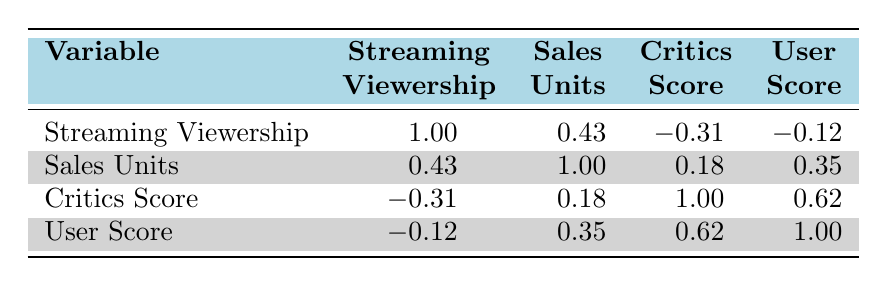What is the correlation coefficient between streaming viewership hours and game sales units? The correlation table indicates that the value for the correlation between streaming viewership and sales units is 0.43.
Answer: 0.43 Is there a positive correlation between user score and game sales units? Yes, the correlation value between user score and sales units is 0.35, which indicates a positive relationship.
Answer: Yes What is the overall correlation coefficient for critics score with streaming viewership? The table shows a correlation coefficient of -0.31 between critics score and streaming viewership, indicating a negative correlation.
Answer: -0.31 What is the average correlation coefficient between the user score and the critics score? The average correlation value is calculated by adding the correlation coefficients for user score (0.62) and user score (0.62) and dividing by the number of scores (1): (0.62)/1 = 0.62.
Answer: 0.62 Are the streaming viewership and user score negatively correlated? No, the table shows a correlation value of -0.12 between streaming viewership and user score, which indicates a weak negative correlation.
Answer: No What is the maximum correlation value found in the table? The maximum correlation value is 1.00, which is the correlation of each variable with itself (streaming viewership with itself).
Answer: 1.00 How would you interpret the correlation coefficient of 0.43 between streaming viewership and sales units? A correlation coefficient of 0.43 suggests a moderate positive relationship, meaning as streaming viewership increases, game sales units tend to also increase, but not perfectly.
Answer: Moderate positive relationship Is the critics score correlated with streaming viewership hours at a significant level? Yes, with -0.31 indicating a moderate negative correlation, reflects that as viewership hours increase, critics scores tend to decrease.
Answer: Yes What is the correlation coefficient between the user score and the critics score? The correlation coefficient between user score and critics score is 0.62, indicating a strong positive correlation.
Answer: 0.62 